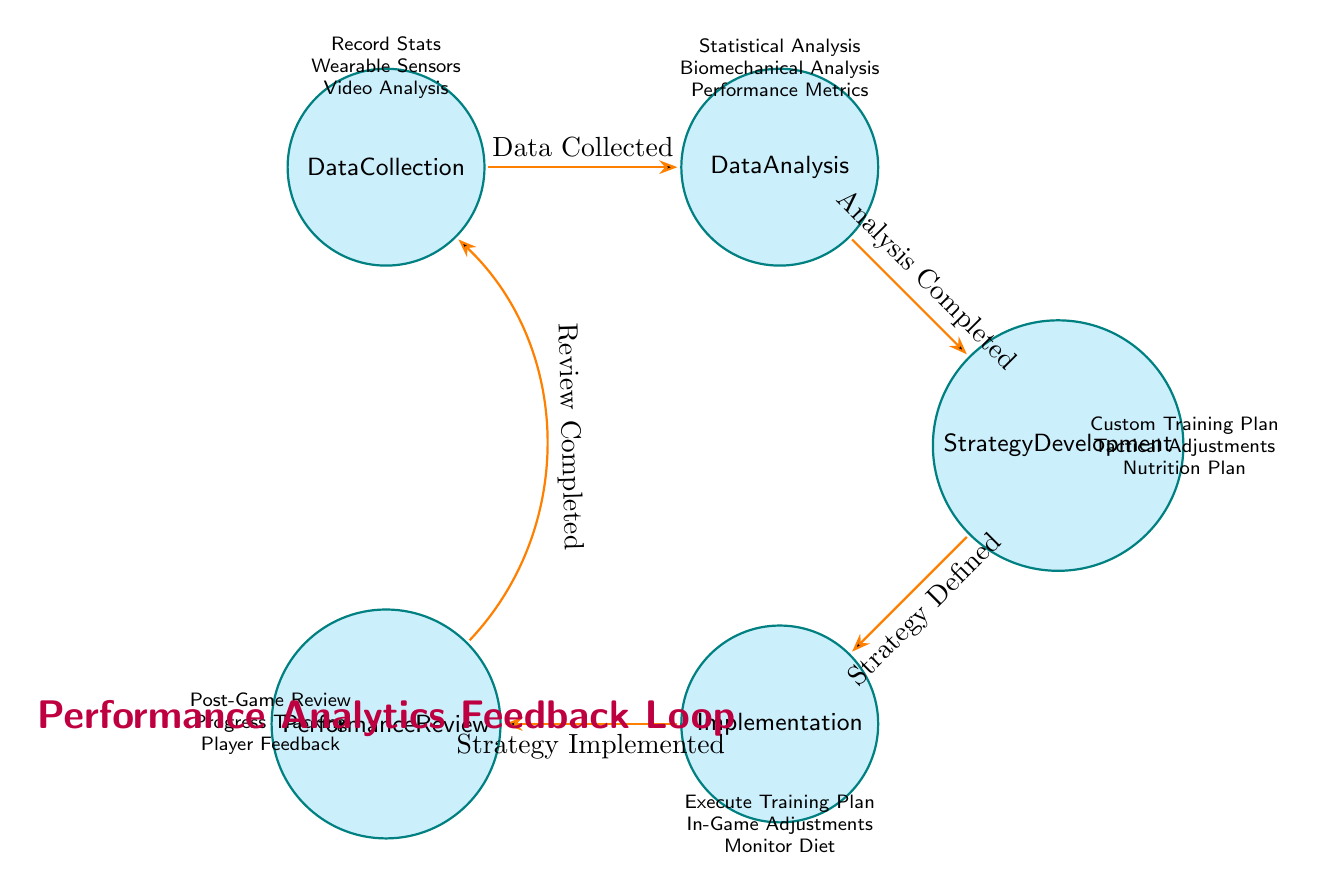What is the initial state in the performance analytics feedback loop? The initial state of the feedback loop is the first node, which is Data Collection.
Answer: Data Collection What action is associated with the Data Analysis state? The actions associated with the Data Analysis state include Statistical Analysis, Biomechanical Analysis, and Performance Metrics. One common action is Statistical Analysis.
Answer: Statistical Analysis How many states are there in the diagram? The diagram lists five unique states: Data Collection, Data Analysis, Strategy Development, Implementation, and Performance Review. Therefore, there are a total of five states.
Answer: Five What is the transition condition from Data Analysis to Strategy Development? The transition from Data Analysis to Strategy Development occurs under the condition that the Analysis is completed.
Answer: Analysis Completed What is the final state that leads back to Data Collection? The final state that transitions back to Data Collection is Performance Review after the review has been completed.
Answer: Performance Review What are the actions listed under the Implementation state? Under the Implementation state, the actions include Execute Training Plan, In-Game Adjustments, and Monitor Diet. One actionable item is Execute Training Plan.
Answer: Execute Training Plan What condition must be met to transition from Strategy Development to Implementation? To transition from Strategy Development to Implementation, the condition that must be met is that the Strategy is defined.
Answer: Strategy Defined Which state involves reviewing performance outcomes? The state that involves reviewing performance outcomes is Performance Review, which is essential for assessing effectiveness of strategies.
Answer: Performance Review How does the Feedback Loop cycle progress? The feedback loop progresses as follows: Data Collection to Data Analysis, then to Strategy Development, followed by Implementation, and concluding with Performance Review, which leads back to Data Collection upon completion.
Answer: Data Collection to Performance Review to Data Collection 